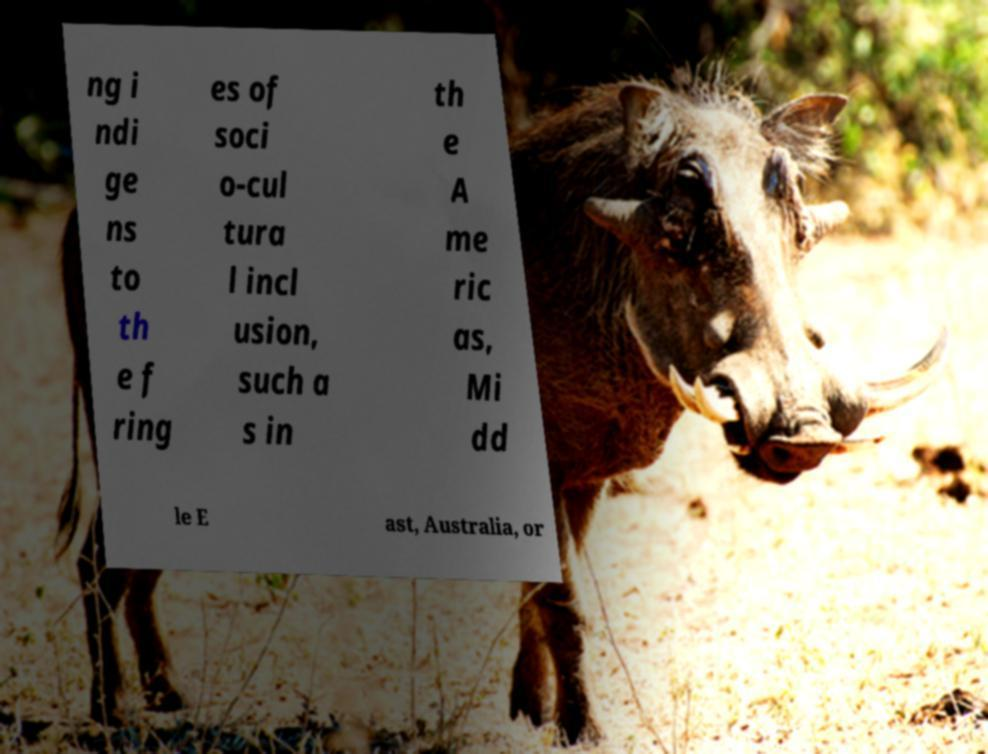Please identify and transcribe the text found in this image. ng i ndi ge ns to th e f ring es of soci o-cul tura l incl usion, such a s in th e A me ric as, Mi dd le E ast, Australia, or 